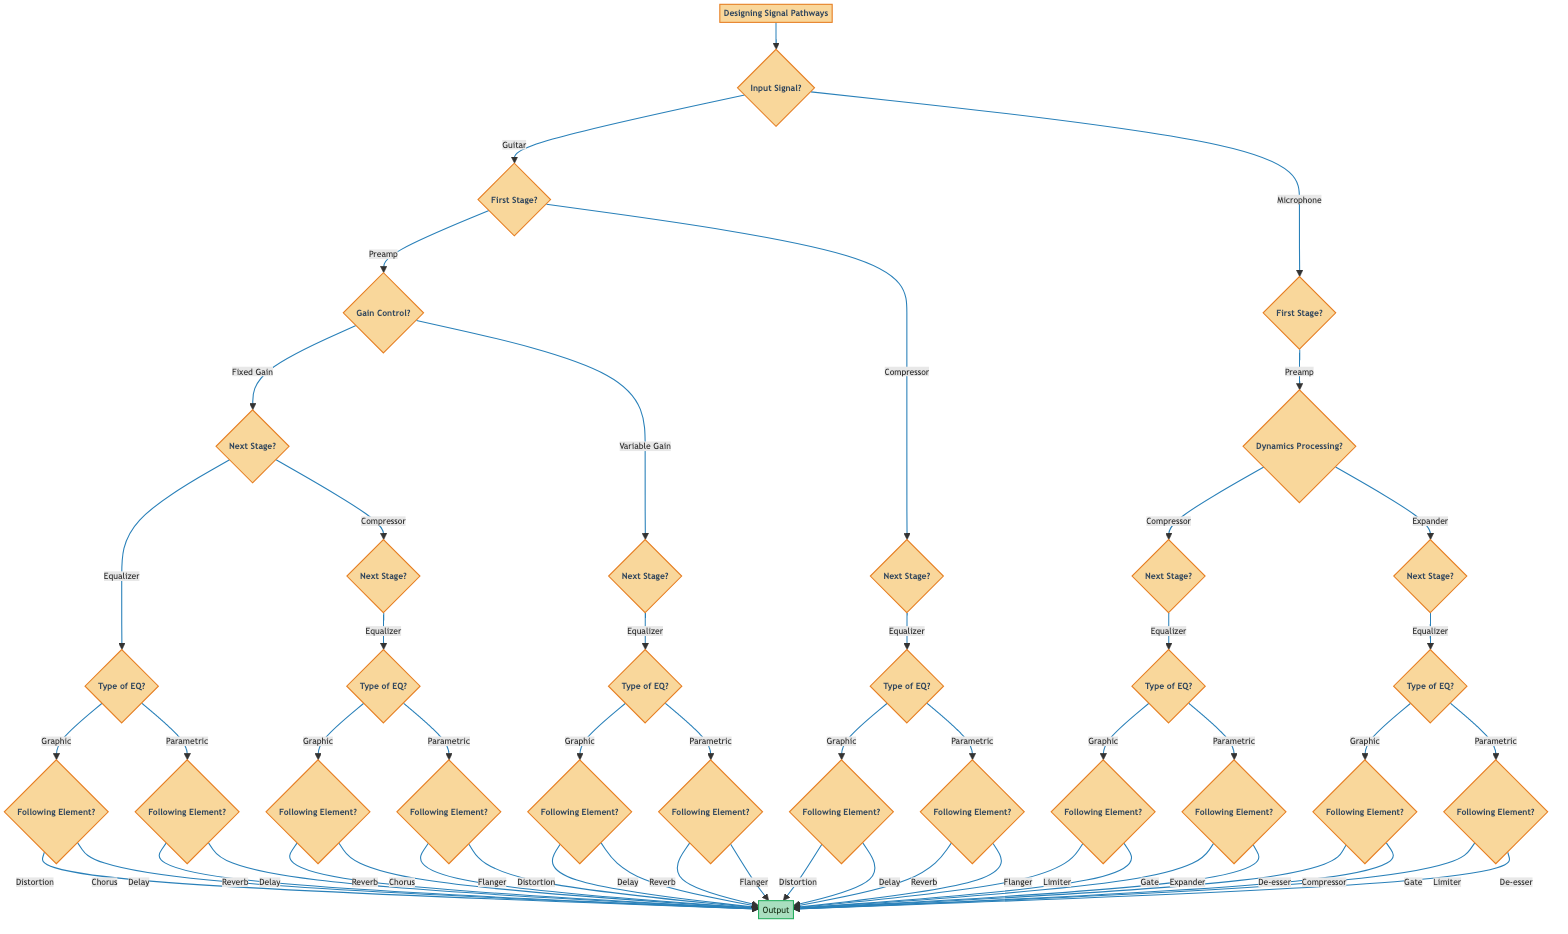What is the first stage if the input signal is a guitar? If the input signal is a guitar, the first stage in the signal pathway according to the diagram is either a Preamp or Compressor, as these are the two initial options presented for processing a guitar signal.
Answer: Preamp or Compressor What follows a Fixed Gain preamp? After the Fixed Gain preamp, the next stage is an Equalizer. This follows the path from the Fixed Gain option, which specifies that the next node is the Equalizer.
Answer: Equalizer How many types of equalizers are available in this diagram? The diagram presents two types of equalizers: Graphic and Parametric. These types are defined as options for the Equalizer node across different signal pathways.
Answer: Two What is the final stage after a Graphic equalizer followed by Distortion? After a Graphic equalizer followed by a Distortion, the final stage is an Output. This is indicated under the Graphic equalizer and Distortion linkage.
Answer: Output What type of dynamics processing can you select after the microphone preamp? After the microphone preamp, you can select either a Compressor or an Expander for dynamics processing. These options are displayed as branches from the Preamp node.
Answer: Compressor or Expander If the signal path includes an Expander and then a Graphic equalizer, what is the final output stage? Following an Expander and a Graphic equalizer, the next possibility could be either a Compressor or a Gate. Both are listed as options following the Graphic equalizer node, and either could be a final output stage, leading to the Output node.
Answer: Compressor or Gate What follows a Variable Gain preamp? After a Variable Gain preamp, the next stage is also an Equalizer, similar to the Fixed Gain preamp pathway. This option directs the signal to an Equalizer immediately after the Variable Gain preamp.
Answer: Equalizer What element follows a Parametric equalizer and a Flanger? Following a Parametric equalizer and a Flanger, the final stage is an Output. The diagram specifies this output after the sequences involving the Parametric equalizer.
Answer: Output What is the last stage for a Compressor after a mic's dynamics processing and a Parametric equalizer? The last stage for a Compressor that follows the mic's dynamics processing and a Parametric equalizer is an Output. This pathway leads directly to the Output node.
Answer: Output 